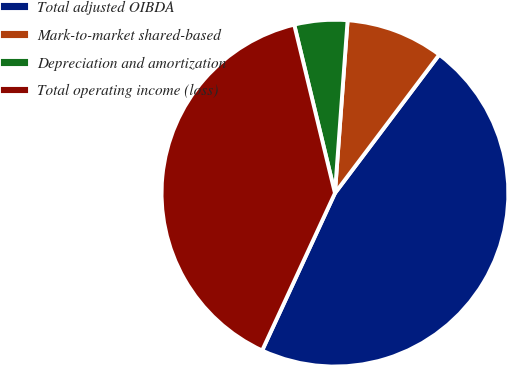Convert chart to OTSL. <chart><loc_0><loc_0><loc_500><loc_500><pie_chart><fcel>Total adjusted OIBDA<fcel>Mark-to-market shared-based<fcel>Depreciation and amortization<fcel>Total operating income (loss)<nl><fcel>46.63%<fcel>9.11%<fcel>4.94%<fcel>39.33%<nl></chart> 